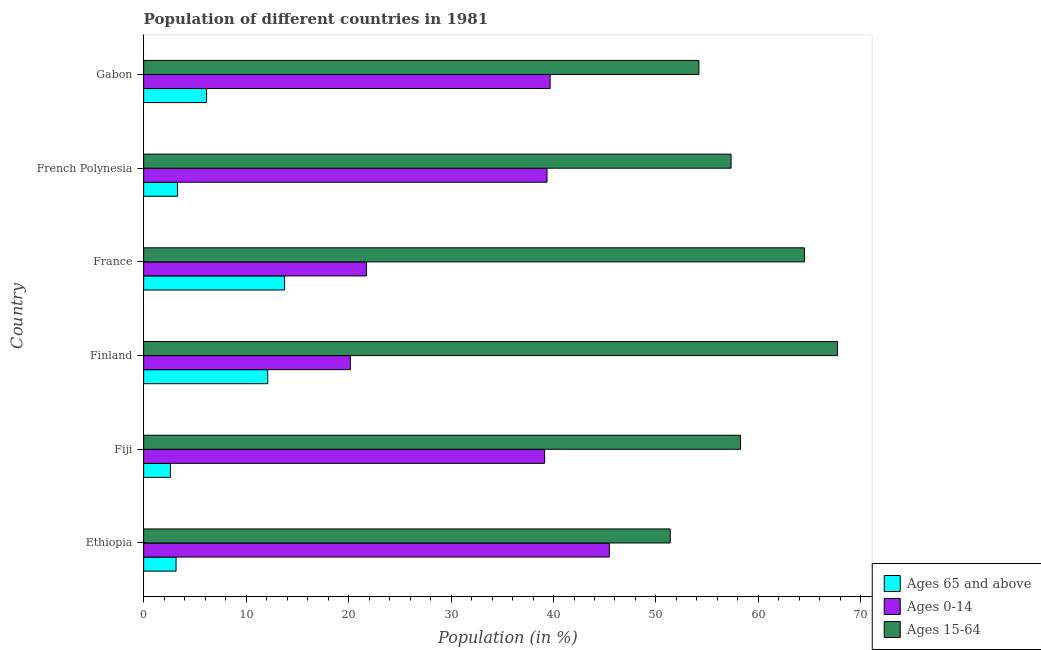How many groups of bars are there?
Your answer should be very brief. 6. Are the number of bars on each tick of the Y-axis equal?
Give a very brief answer. Yes. How many bars are there on the 4th tick from the top?
Provide a short and direct response. 3. How many bars are there on the 1st tick from the bottom?
Provide a succinct answer. 3. In how many cases, is the number of bars for a given country not equal to the number of legend labels?
Your answer should be very brief. 0. What is the percentage of population within the age-group of 65 and above in French Polynesia?
Provide a succinct answer. 3.3. Across all countries, what is the maximum percentage of population within the age-group 0-14?
Keep it short and to the point. 45.45. Across all countries, what is the minimum percentage of population within the age-group 0-14?
Offer a terse response. 20.17. In which country was the percentage of population within the age-group 15-64 maximum?
Offer a very short reply. Finland. In which country was the percentage of population within the age-group of 65 and above minimum?
Provide a short and direct response. Fiji. What is the total percentage of population within the age-group 0-14 in the graph?
Offer a very short reply. 205.53. What is the difference between the percentage of population within the age-group of 65 and above in Ethiopia and that in Finland?
Your answer should be very brief. -8.95. What is the difference between the percentage of population within the age-group 15-64 in Finland and the percentage of population within the age-group of 65 and above in Gabon?
Your answer should be compact. 61.58. What is the average percentage of population within the age-group of 65 and above per country?
Keep it short and to the point. 6.85. What is the difference between the percentage of population within the age-group 0-14 and percentage of population within the age-group of 65 and above in Ethiopia?
Provide a short and direct response. 42.28. What is the ratio of the percentage of population within the age-group 15-64 in Fiji to that in Finland?
Your response must be concise. 0.86. Is the difference between the percentage of population within the age-group of 65 and above in Ethiopia and Fiji greater than the difference between the percentage of population within the age-group 0-14 in Ethiopia and Fiji?
Keep it short and to the point. No. What is the difference between the highest and the second highest percentage of population within the age-group 15-64?
Offer a terse response. 3.23. What is the difference between the highest and the lowest percentage of population within the age-group of 65 and above?
Offer a terse response. 11.14. Is the sum of the percentage of population within the age-group 15-64 in Fiji and Gabon greater than the maximum percentage of population within the age-group of 65 and above across all countries?
Give a very brief answer. Yes. What does the 3rd bar from the top in Gabon represents?
Your answer should be very brief. Ages 65 and above. What does the 2nd bar from the bottom in Gabon represents?
Make the answer very short. Ages 0-14. How many bars are there?
Offer a very short reply. 18. How many countries are there in the graph?
Your response must be concise. 6. Does the graph contain any zero values?
Offer a terse response. No. Where does the legend appear in the graph?
Keep it short and to the point. Bottom right. How many legend labels are there?
Provide a succinct answer. 3. How are the legend labels stacked?
Offer a very short reply. Vertical. What is the title of the graph?
Provide a short and direct response. Population of different countries in 1981. What is the Population (in %) of Ages 65 and above in Ethiopia?
Your answer should be very brief. 3.16. What is the Population (in %) in Ages 0-14 in Ethiopia?
Offer a terse response. 45.45. What is the Population (in %) of Ages 15-64 in Ethiopia?
Ensure brevity in your answer.  51.39. What is the Population (in %) in Ages 65 and above in Fiji?
Keep it short and to the point. 2.61. What is the Population (in %) of Ages 0-14 in Fiji?
Keep it short and to the point. 39.13. What is the Population (in %) of Ages 15-64 in Fiji?
Offer a terse response. 58.26. What is the Population (in %) in Ages 65 and above in Finland?
Offer a terse response. 12.11. What is the Population (in %) of Ages 0-14 in Finland?
Offer a very short reply. 20.17. What is the Population (in %) of Ages 15-64 in Finland?
Provide a succinct answer. 67.72. What is the Population (in %) in Ages 65 and above in France?
Give a very brief answer. 13.76. What is the Population (in %) of Ages 0-14 in France?
Your answer should be very brief. 21.75. What is the Population (in %) in Ages 15-64 in France?
Ensure brevity in your answer.  64.49. What is the Population (in %) in Ages 65 and above in French Polynesia?
Ensure brevity in your answer.  3.3. What is the Population (in %) in Ages 0-14 in French Polynesia?
Ensure brevity in your answer.  39.37. What is the Population (in %) of Ages 15-64 in French Polynesia?
Offer a terse response. 57.33. What is the Population (in %) of Ages 65 and above in Gabon?
Offer a terse response. 6.14. What is the Population (in %) of Ages 0-14 in Gabon?
Ensure brevity in your answer.  39.67. What is the Population (in %) of Ages 15-64 in Gabon?
Offer a very short reply. 54.19. Across all countries, what is the maximum Population (in %) of Ages 65 and above?
Make the answer very short. 13.76. Across all countries, what is the maximum Population (in %) of Ages 0-14?
Your response must be concise. 45.45. Across all countries, what is the maximum Population (in %) in Ages 15-64?
Give a very brief answer. 67.72. Across all countries, what is the minimum Population (in %) of Ages 65 and above?
Offer a very short reply. 2.61. Across all countries, what is the minimum Population (in %) in Ages 0-14?
Provide a short and direct response. 20.17. Across all countries, what is the minimum Population (in %) of Ages 15-64?
Your answer should be very brief. 51.39. What is the total Population (in %) in Ages 65 and above in the graph?
Provide a succinct answer. 41.09. What is the total Population (in %) of Ages 0-14 in the graph?
Offer a terse response. 205.53. What is the total Population (in %) in Ages 15-64 in the graph?
Provide a succinct answer. 353.38. What is the difference between the Population (in %) of Ages 65 and above in Ethiopia and that in Fiji?
Offer a very short reply. 0.55. What is the difference between the Population (in %) of Ages 0-14 in Ethiopia and that in Fiji?
Make the answer very short. 6.32. What is the difference between the Population (in %) in Ages 15-64 in Ethiopia and that in Fiji?
Ensure brevity in your answer.  -6.87. What is the difference between the Population (in %) of Ages 65 and above in Ethiopia and that in Finland?
Offer a terse response. -8.95. What is the difference between the Population (in %) in Ages 0-14 in Ethiopia and that in Finland?
Your answer should be compact. 25.28. What is the difference between the Population (in %) of Ages 15-64 in Ethiopia and that in Finland?
Offer a terse response. -16.33. What is the difference between the Population (in %) of Ages 65 and above in Ethiopia and that in France?
Offer a terse response. -10.59. What is the difference between the Population (in %) in Ages 0-14 in Ethiopia and that in France?
Keep it short and to the point. 23.69. What is the difference between the Population (in %) of Ages 65 and above in Ethiopia and that in French Polynesia?
Make the answer very short. -0.14. What is the difference between the Population (in %) of Ages 0-14 in Ethiopia and that in French Polynesia?
Keep it short and to the point. 6.08. What is the difference between the Population (in %) of Ages 15-64 in Ethiopia and that in French Polynesia?
Your response must be concise. -5.94. What is the difference between the Population (in %) of Ages 65 and above in Ethiopia and that in Gabon?
Provide a short and direct response. -2.98. What is the difference between the Population (in %) of Ages 0-14 in Ethiopia and that in Gabon?
Provide a short and direct response. 5.78. What is the difference between the Population (in %) of Ages 15-64 in Ethiopia and that in Gabon?
Keep it short and to the point. -2.8. What is the difference between the Population (in %) of Ages 65 and above in Fiji and that in Finland?
Your answer should be very brief. -9.5. What is the difference between the Population (in %) of Ages 0-14 in Fiji and that in Finland?
Make the answer very short. 18.96. What is the difference between the Population (in %) in Ages 15-64 in Fiji and that in Finland?
Make the answer very short. -9.46. What is the difference between the Population (in %) in Ages 65 and above in Fiji and that in France?
Your answer should be compact. -11.14. What is the difference between the Population (in %) of Ages 0-14 in Fiji and that in France?
Make the answer very short. 17.38. What is the difference between the Population (in %) of Ages 15-64 in Fiji and that in France?
Provide a succinct answer. -6.23. What is the difference between the Population (in %) of Ages 65 and above in Fiji and that in French Polynesia?
Offer a terse response. -0.69. What is the difference between the Population (in %) of Ages 0-14 in Fiji and that in French Polynesia?
Provide a short and direct response. -0.24. What is the difference between the Population (in %) of Ages 15-64 in Fiji and that in French Polynesia?
Keep it short and to the point. 0.93. What is the difference between the Population (in %) in Ages 65 and above in Fiji and that in Gabon?
Provide a succinct answer. -3.53. What is the difference between the Population (in %) in Ages 0-14 in Fiji and that in Gabon?
Provide a succinct answer. -0.54. What is the difference between the Population (in %) in Ages 15-64 in Fiji and that in Gabon?
Keep it short and to the point. 4.07. What is the difference between the Population (in %) in Ages 65 and above in Finland and that in France?
Your response must be concise. -1.65. What is the difference between the Population (in %) in Ages 0-14 in Finland and that in France?
Provide a short and direct response. -1.58. What is the difference between the Population (in %) of Ages 15-64 in Finland and that in France?
Your response must be concise. 3.23. What is the difference between the Population (in %) of Ages 65 and above in Finland and that in French Polynesia?
Offer a very short reply. 8.81. What is the difference between the Population (in %) in Ages 0-14 in Finland and that in French Polynesia?
Keep it short and to the point. -19.2. What is the difference between the Population (in %) of Ages 15-64 in Finland and that in French Polynesia?
Offer a terse response. 10.39. What is the difference between the Population (in %) of Ages 65 and above in Finland and that in Gabon?
Keep it short and to the point. 5.97. What is the difference between the Population (in %) of Ages 0-14 in Finland and that in Gabon?
Keep it short and to the point. -19.5. What is the difference between the Population (in %) of Ages 15-64 in Finland and that in Gabon?
Ensure brevity in your answer.  13.53. What is the difference between the Population (in %) of Ages 65 and above in France and that in French Polynesia?
Give a very brief answer. 10.45. What is the difference between the Population (in %) in Ages 0-14 in France and that in French Polynesia?
Make the answer very short. -17.61. What is the difference between the Population (in %) in Ages 15-64 in France and that in French Polynesia?
Provide a short and direct response. 7.16. What is the difference between the Population (in %) of Ages 65 and above in France and that in Gabon?
Give a very brief answer. 7.62. What is the difference between the Population (in %) of Ages 0-14 in France and that in Gabon?
Your answer should be compact. -17.92. What is the difference between the Population (in %) of Ages 15-64 in France and that in Gabon?
Offer a terse response. 10.3. What is the difference between the Population (in %) in Ages 65 and above in French Polynesia and that in Gabon?
Offer a terse response. -2.84. What is the difference between the Population (in %) of Ages 0-14 in French Polynesia and that in Gabon?
Make the answer very short. -0.3. What is the difference between the Population (in %) in Ages 15-64 in French Polynesia and that in Gabon?
Your response must be concise. 3.14. What is the difference between the Population (in %) of Ages 65 and above in Ethiopia and the Population (in %) of Ages 0-14 in Fiji?
Make the answer very short. -35.97. What is the difference between the Population (in %) in Ages 65 and above in Ethiopia and the Population (in %) in Ages 15-64 in Fiji?
Your answer should be compact. -55.09. What is the difference between the Population (in %) of Ages 0-14 in Ethiopia and the Population (in %) of Ages 15-64 in Fiji?
Offer a very short reply. -12.81. What is the difference between the Population (in %) of Ages 65 and above in Ethiopia and the Population (in %) of Ages 0-14 in Finland?
Your answer should be compact. -17.01. What is the difference between the Population (in %) of Ages 65 and above in Ethiopia and the Population (in %) of Ages 15-64 in Finland?
Give a very brief answer. -64.56. What is the difference between the Population (in %) of Ages 0-14 in Ethiopia and the Population (in %) of Ages 15-64 in Finland?
Keep it short and to the point. -22.27. What is the difference between the Population (in %) of Ages 65 and above in Ethiopia and the Population (in %) of Ages 0-14 in France?
Offer a terse response. -18.59. What is the difference between the Population (in %) in Ages 65 and above in Ethiopia and the Population (in %) in Ages 15-64 in France?
Give a very brief answer. -61.33. What is the difference between the Population (in %) in Ages 0-14 in Ethiopia and the Population (in %) in Ages 15-64 in France?
Provide a succinct answer. -19.04. What is the difference between the Population (in %) of Ages 65 and above in Ethiopia and the Population (in %) of Ages 0-14 in French Polynesia?
Your answer should be very brief. -36.2. What is the difference between the Population (in %) of Ages 65 and above in Ethiopia and the Population (in %) of Ages 15-64 in French Polynesia?
Provide a succinct answer. -54.17. What is the difference between the Population (in %) in Ages 0-14 in Ethiopia and the Population (in %) in Ages 15-64 in French Polynesia?
Ensure brevity in your answer.  -11.88. What is the difference between the Population (in %) of Ages 65 and above in Ethiopia and the Population (in %) of Ages 0-14 in Gabon?
Your response must be concise. -36.51. What is the difference between the Population (in %) in Ages 65 and above in Ethiopia and the Population (in %) in Ages 15-64 in Gabon?
Give a very brief answer. -51.03. What is the difference between the Population (in %) of Ages 0-14 in Ethiopia and the Population (in %) of Ages 15-64 in Gabon?
Make the answer very short. -8.74. What is the difference between the Population (in %) of Ages 65 and above in Fiji and the Population (in %) of Ages 0-14 in Finland?
Make the answer very short. -17.56. What is the difference between the Population (in %) of Ages 65 and above in Fiji and the Population (in %) of Ages 15-64 in Finland?
Offer a very short reply. -65.11. What is the difference between the Population (in %) in Ages 0-14 in Fiji and the Population (in %) in Ages 15-64 in Finland?
Make the answer very short. -28.59. What is the difference between the Population (in %) of Ages 65 and above in Fiji and the Population (in %) of Ages 0-14 in France?
Offer a terse response. -19.14. What is the difference between the Population (in %) of Ages 65 and above in Fiji and the Population (in %) of Ages 15-64 in France?
Provide a succinct answer. -61.88. What is the difference between the Population (in %) in Ages 0-14 in Fiji and the Population (in %) in Ages 15-64 in France?
Provide a succinct answer. -25.36. What is the difference between the Population (in %) of Ages 65 and above in Fiji and the Population (in %) of Ages 0-14 in French Polynesia?
Provide a short and direct response. -36.75. What is the difference between the Population (in %) of Ages 65 and above in Fiji and the Population (in %) of Ages 15-64 in French Polynesia?
Your answer should be compact. -54.72. What is the difference between the Population (in %) in Ages 0-14 in Fiji and the Population (in %) in Ages 15-64 in French Polynesia?
Your answer should be very brief. -18.2. What is the difference between the Population (in %) in Ages 65 and above in Fiji and the Population (in %) in Ages 0-14 in Gabon?
Give a very brief answer. -37.05. What is the difference between the Population (in %) in Ages 65 and above in Fiji and the Population (in %) in Ages 15-64 in Gabon?
Your answer should be compact. -51.58. What is the difference between the Population (in %) in Ages 0-14 in Fiji and the Population (in %) in Ages 15-64 in Gabon?
Your answer should be compact. -15.06. What is the difference between the Population (in %) in Ages 65 and above in Finland and the Population (in %) in Ages 0-14 in France?
Make the answer very short. -9.64. What is the difference between the Population (in %) of Ages 65 and above in Finland and the Population (in %) of Ages 15-64 in France?
Offer a terse response. -52.38. What is the difference between the Population (in %) in Ages 0-14 in Finland and the Population (in %) in Ages 15-64 in France?
Offer a terse response. -44.32. What is the difference between the Population (in %) of Ages 65 and above in Finland and the Population (in %) of Ages 0-14 in French Polynesia?
Your response must be concise. -27.26. What is the difference between the Population (in %) of Ages 65 and above in Finland and the Population (in %) of Ages 15-64 in French Polynesia?
Your response must be concise. -45.22. What is the difference between the Population (in %) of Ages 0-14 in Finland and the Population (in %) of Ages 15-64 in French Polynesia?
Give a very brief answer. -37.16. What is the difference between the Population (in %) in Ages 65 and above in Finland and the Population (in %) in Ages 0-14 in Gabon?
Your answer should be very brief. -27.56. What is the difference between the Population (in %) in Ages 65 and above in Finland and the Population (in %) in Ages 15-64 in Gabon?
Provide a succinct answer. -42.08. What is the difference between the Population (in %) of Ages 0-14 in Finland and the Population (in %) of Ages 15-64 in Gabon?
Give a very brief answer. -34.02. What is the difference between the Population (in %) in Ages 65 and above in France and the Population (in %) in Ages 0-14 in French Polynesia?
Your answer should be compact. -25.61. What is the difference between the Population (in %) in Ages 65 and above in France and the Population (in %) in Ages 15-64 in French Polynesia?
Your response must be concise. -43.57. What is the difference between the Population (in %) of Ages 0-14 in France and the Population (in %) of Ages 15-64 in French Polynesia?
Offer a terse response. -35.58. What is the difference between the Population (in %) in Ages 65 and above in France and the Population (in %) in Ages 0-14 in Gabon?
Make the answer very short. -25.91. What is the difference between the Population (in %) in Ages 65 and above in France and the Population (in %) in Ages 15-64 in Gabon?
Provide a succinct answer. -40.43. What is the difference between the Population (in %) of Ages 0-14 in France and the Population (in %) of Ages 15-64 in Gabon?
Your response must be concise. -32.44. What is the difference between the Population (in %) in Ages 65 and above in French Polynesia and the Population (in %) in Ages 0-14 in Gabon?
Keep it short and to the point. -36.37. What is the difference between the Population (in %) in Ages 65 and above in French Polynesia and the Population (in %) in Ages 15-64 in Gabon?
Your response must be concise. -50.89. What is the difference between the Population (in %) of Ages 0-14 in French Polynesia and the Population (in %) of Ages 15-64 in Gabon?
Make the answer very short. -14.82. What is the average Population (in %) in Ages 65 and above per country?
Your answer should be compact. 6.85. What is the average Population (in %) in Ages 0-14 per country?
Keep it short and to the point. 34.26. What is the average Population (in %) in Ages 15-64 per country?
Your response must be concise. 58.9. What is the difference between the Population (in %) of Ages 65 and above and Population (in %) of Ages 0-14 in Ethiopia?
Provide a short and direct response. -42.28. What is the difference between the Population (in %) in Ages 65 and above and Population (in %) in Ages 15-64 in Ethiopia?
Provide a succinct answer. -48.23. What is the difference between the Population (in %) of Ages 0-14 and Population (in %) of Ages 15-64 in Ethiopia?
Your answer should be compact. -5.94. What is the difference between the Population (in %) of Ages 65 and above and Population (in %) of Ages 0-14 in Fiji?
Give a very brief answer. -36.52. What is the difference between the Population (in %) in Ages 65 and above and Population (in %) in Ages 15-64 in Fiji?
Keep it short and to the point. -55.64. What is the difference between the Population (in %) of Ages 0-14 and Population (in %) of Ages 15-64 in Fiji?
Provide a short and direct response. -19.13. What is the difference between the Population (in %) of Ages 65 and above and Population (in %) of Ages 0-14 in Finland?
Offer a very short reply. -8.06. What is the difference between the Population (in %) of Ages 65 and above and Population (in %) of Ages 15-64 in Finland?
Your answer should be compact. -55.61. What is the difference between the Population (in %) of Ages 0-14 and Population (in %) of Ages 15-64 in Finland?
Offer a very short reply. -47.55. What is the difference between the Population (in %) of Ages 65 and above and Population (in %) of Ages 0-14 in France?
Offer a terse response. -8. What is the difference between the Population (in %) in Ages 65 and above and Population (in %) in Ages 15-64 in France?
Give a very brief answer. -50.73. What is the difference between the Population (in %) of Ages 0-14 and Population (in %) of Ages 15-64 in France?
Give a very brief answer. -42.74. What is the difference between the Population (in %) of Ages 65 and above and Population (in %) of Ages 0-14 in French Polynesia?
Your answer should be very brief. -36.06. What is the difference between the Population (in %) of Ages 65 and above and Population (in %) of Ages 15-64 in French Polynesia?
Provide a short and direct response. -54.03. What is the difference between the Population (in %) of Ages 0-14 and Population (in %) of Ages 15-64 in French Polynesia?
Offer a terse response. -17.96. What is the difference between the Population (in %) of Ages 65 and above and Population (in %) of Ages 0-14 in Gabon?
Make the answer very short. -33.53. What is the difference between the Population (in %) in Ages 65 and above and Population (in %) in Ages 15-64 in Gabon?
Provide a succinct answer. -48.05. What is the difference between the Population (in %) of Ages 0-14 and Population (in %) of Ages 15-64 in Gabon?
Offer a very short reply. -14.52. What is the ratio of the Population (in %) in Ages 65 and above in Ethiopia to that in Fiji?
Your answer should be compact. 1.21. What is the ratio of the Population (in %) in Ages 0-14 in Ethiopia to that in Fiji?
Make the answer very short. 1.16. What is the ratio of the Population (in %) of Ages 15-64 in Ethiopia to that in Fiji?
Make the answer very short. 0.88. What is the ratio of the Population (in %) in Ages 65 and above in Ethiopia to that in Finland?
Your answer should be compact. 0.26. What is the ratio of the Population (in %) in Ages 0-14 in Ethiopia to that in Finland?
Offer a terse response. 2.25. What is the ratio of the Population (in %) in Ages 15-64 in Ethiopia to that in Finland?
Your response must be concise. 0.76. What is the ratio of the Population (in %) of Ages 65 and above in Ethiopia to that in France?
Ensure brevity in your answer.  0.23. What is the ratio of the Population (in %) in Ages 0-14 in Ethiopia to that in France?
Offer a very short reply. 2.09. What is the ratio of the Population (in %) of Ages 15-64 in Ethiopia to that in France?
Give a very brief answer. 0.8. What is the ratio of the Population (in %) in Ages 65 and above in Ethiopia to that in French Polynesia?
Make the answer very short. 0.96. What is the ratio of the Population (in %) of Ages 0-14 in Ethiopia to that in French Polynesia?
Keep it short and to the point. 1.15. What is the ratio of the Population (in %) of Ages 15-64 in Ethiopia to that in French Polynesia?
Provide a succinct answer. 0.9. What is the ratio of the Population (in %) of Ages 65 and above in Ethiopia to that in Gabon?
Ensure brevity in your answer.  0.52. What is the ratio of the Population (in %) in Ages 0-14 in Ethiopia to that in Gabon?
Make the answer very short. 1.15. What is the ratio of the Population (in %) of Ages 15-64 in Ethiopia to that in Gabon?
Your response must be concise. 0.95. What is the ratio of the Population (in %) in Ages 65 and above in Fiji to that in Finland?
Keep it short and to the point. 0.22. What is the ratio of the Population (in %) in Ages 0-14 in Fiji to that in Finland?
Keep it short and to the point. 1.94. What is the ratio of the Population (in %) of Ages 15-64 in Fiji to that in Finland?
Ensure brevity in your answer.  0.86. What is the ratio of the Population (in %) in Ages 65 and above in Fiji to that in France?
Offer a very short reply. 0.19. What is the ratio of the Population (in %) in Ages 0-14 in Fiji to that in France?
Ensure brevity in your answer.  1.8. What is the ratio of the Population (in %) of Ages 15-64 in Fiji to that in France?
Provide a short and direct response. 0.9. What is the ratio of the Population (in %) of Ages 65 and above in Fiji to that in French Polynesia?
Provide a short and direct response. 0.79. What is the ratio of the Population (in %) in Ages 15-64 in Fiji to that in French Polynesia?
Provide a short and direct response. 1.02. What is the ratio of the Population (in %) in Ages 65 and above in Fiji to that in Gabon?
Your response must be concise. 0.43. What is the ratio of the Population (in %) in Ages 0-14 in Fiji to that in Gabon?
Keep it short and to the point. 0.99. What is the ratio of the Population (in %) in Ages 15-64 in Fiji to that in Gabon?
Give a very brief answer. 1.07. What is the ratio of the Population (in %) in Ages 65 and above in Finland to that in France?
Offer a terse response. 0.88. What is the ratio of the Population (in %) of Ages 0-14 in Finland to that in France?
Give a very brief answer. 0.93. What is the ratio of the Population (in %) of Ages 15-64 in Finland to that in France?
Your answer should be very brief. 1.05. What is the ratio of the Population (in %) in Ages 65 and above in Finland to that in French Polynesia?
Give a very brief answer. 3.67. What is the ratio of the Population (in %) in Ages 0-14 in Finland to that in French Polynesia?
Provide a succinct answer. 0.51. What is the ratio of the Population (in %) in Ages 15-64 in Finland to that in French Polynesia?
Provide a short and direct response. 1.18. What is the ratio of the Population (in %) in Ages 65 and above in Finland to that in Gabon?
Provide a succinct answer. 1.97. What is the ratio of the Population (in %) of Ages 0-14 in Finland to that in Gabon?
Make the answer very short. 0.51. What is the ratio of the Population (in %) in Ages 15-64 in Finland to that in Gabon?
Ensure brevity in your answer.  1.25. What is the ratio of the Population (in %) of Ages 65 and above in France to that in French Polynesia?
Make the answer very short. 4.17. What is the ratio of the Population (in %) in Ages 0-14 in France to that in French Polynesia?
Make the answer very short. 0.55. What is the ratio of the Population (in %) of Ages 15-64 in France to that in French Polynesia?
Provide a succinct answer. 1.12. What is the ratio of the Population (in %) of Ages 65 and above in France to that in Gabon?
Keep it short and to the point. 2.24. What is the ratio of the Population (in %) in Ages 0-14 in France to that in Gabon?
Keep it short and to the point. 0.55. What is the ratio of the Population (in %) of Ages 15-64 in France to that in Gabon?
Provide a succinct answer. 1.19. What is the ratio of the Population (in %) in Ages 65 and above in French Polynesia to that in Gabon?
Give a very brief answer. 0.54. What is the ratio of the Population (in %) in Ages 15-64 in French Polynesia to that in Gabon?
Keep it short and to the point. 1.06. What is the difference between the highest and the second highest Population (in %) in Ages 65 and above?
Make the answer very short. 1.65. What is the difference between the highest and the second highest Population (in %) of Ages 0-14?
Make the answer very short. 5.78. What is the difference between the highest and the second highest Population (in %) in Ages 15-64?
Keep it short and to the point. 3.23. What is the difference between the highest and the lowest Population (in %) in Ages 65 and above?
Your response must be concise. 11.14. What is the difference between the highest and the lowest Population (in %) of Ages 0-14?
Offer a very short reply. 25.28. What is the difference between the highest and the lowest Population (in %) of Ages 15-64?
Your answer should be very brief. 16.33. 